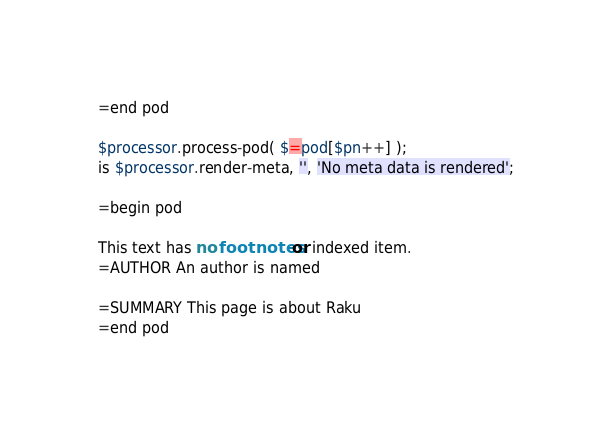Convert code to text. <code><loc_0><loc_0><loc_500><loc_500><_Perl_>=end pod

$processor.process-pod( $=pod[$pn++] );
is $processor.render-meta, '', 'No meta data is rendered';

=begin pod

This text has no footnotes or indexed item.
=AUTHOR An author is named

=SUMMARY This page is about Raku
=end pod
</code> 